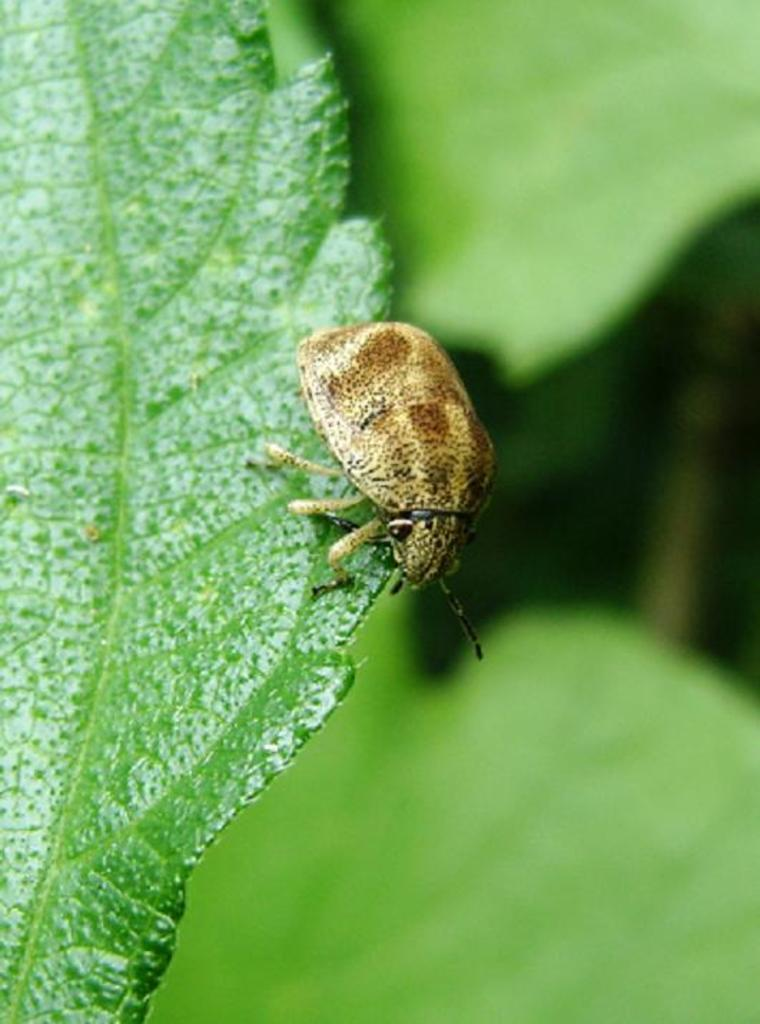What is present in the image? There is an insect in the image. Can you describe the insect's appearance? The insect has cream, black, and brown colors. Where is the insect located? The insect is on a leaf. What color is the leaf? The leaf is green in color. How would you describe the background of the image? The background of the image is blurry. What else can be seen in the background? There are leaves visible in the background. What type of throne does the insect sit on in the image? There is no throne present in the image; the insect is on a leaf. 